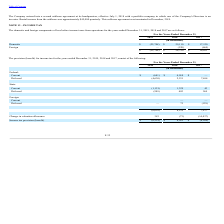From Finjan Holding's financial document, What are the respective domestic income before income taxes in 2018 and 2017?  The document shows two values: 29,110 and 17,120 (in thousands). From the document: "Domestic $ (22,708) $ 29,110 $ 17,120 Domestic $ (22,708) $ 29,110 $ 17,120..." Also, What are the respective foreign income loss before income taxes in 2017 and 2018? The document shows two values: 469 and 320 (in thousands). From the document: "Foreign — (320) (469) Foreign — (320) (469)..." Also, What are the respective total income before tax in 2017 and 2018? The document shows two values: $16,651 and $28,790 (in thousands). From the document: "$ (22,708) $ 28,790 $ 16,651 $ (22,708) $ 28,790 $ 16,651..." Also, can you calculate: What is the percentage change in total income before tax between 2017 and 2018? To answer this question, I need to perform calculations using the financial data. The calculation is: (28,790-16,651)/16,651, which equals 72.9 (percentage). This is based on the information: "$ (22,708) $ 28,790 $ 16,651 $ (22,708) $ 28,790 $ 16,651..." The key data points involved are: 16,651, 28,790. Also, can you calculate: What is the average income before tax in 2017 and 2018? To answer this question, I need to perform calculations using the financial data. The calculation is: (16,651 + 28,790)/2 , which equals 22720.5 (in thousands). This is based on the information: "$ (22,708) $ 28,790 $ 16,651 $ (22,708) $ 28,790 $ 16,651..." The key data points involved are: 16,651, 28,790. Also, can you calculate: What is the total foreign component of loss before income tax in 2017 and 2018? Based on the calculation: 469 + 320 , the result is 789 (in thousands). This is based on the information: "Foreign — (320) (469) Foreign — (320) (469)..." The key data points involved are: 320, 469. 